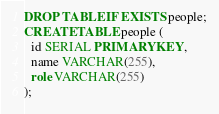<code> <loc_0><loc_0><loc_500><loc_500><_SQL_>DROP TABLE IF EXISTS people;
CREATE TABLE people (
  id SERIAL PRIMARY KEY,
  name VARCHAR(255),
  role VARCHAR(255)
);</code> 